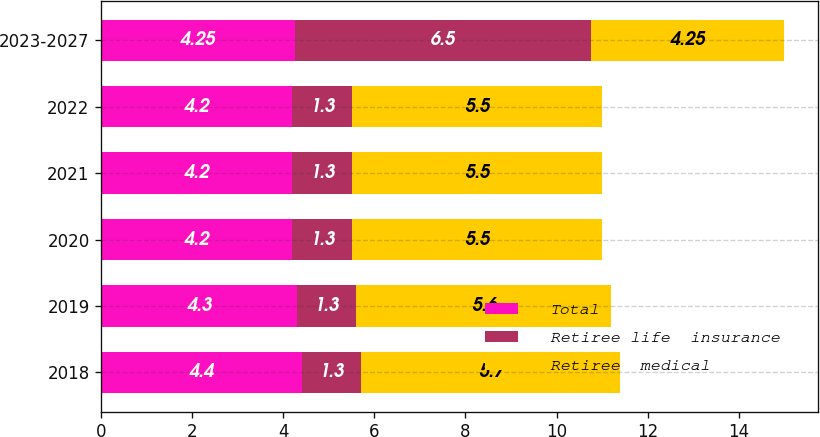Convert chart. <chart><loc_0><loc_0><loc_500><loc_500><stacked_bar_chart><ecel><fcel>2018<fcel>2019<fcel>2020<fcel>2021<fcel>2022<fcel>2023-2027<nl><fcel>Total<fcel>4.4<fcel>4.3<fcel>4.2<fcel>4.2<fcel>4.2<fcel>4.25<nl><fcel>Retiree life  insurance<fcel>1.3<fcel>1.3<fcel>1.3<fcel>1.3<fcel>1.3<fcel>6.5<nl><fcel>Retiree  medical<fcel>5.7<fcel>5.6<fcel>5.5<fcel>5.5<fcel>5.5<fcel>4.25<nl></chart> 